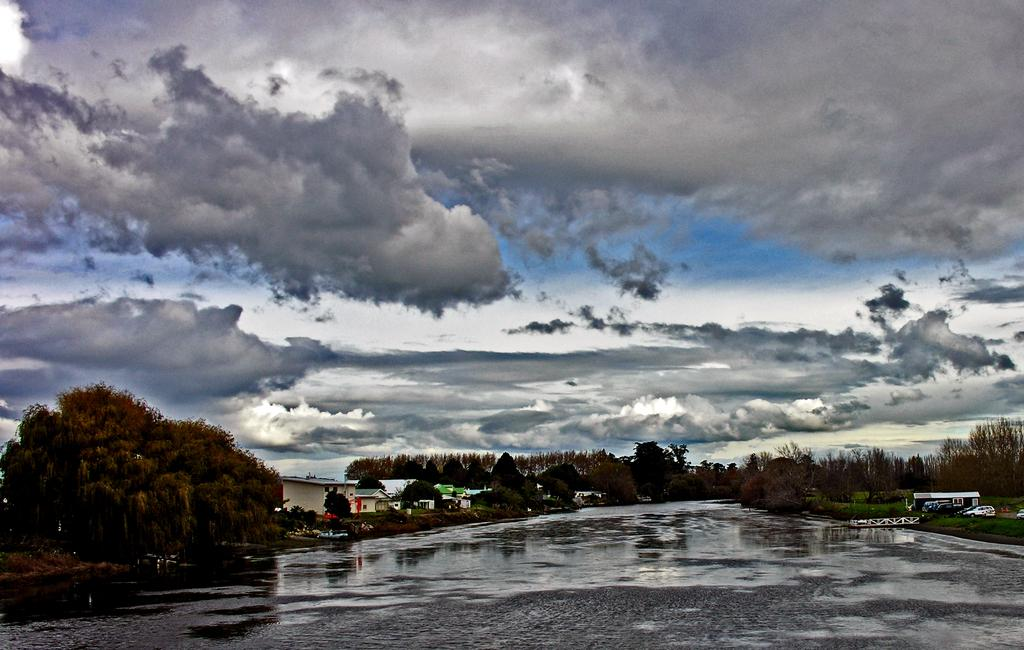What is located in the foreground of the picture? There is a water body in the foreground of the picture. What can be seen in the center of the picture? There are trees, plants, and buildings in the center of the picture. What is the condition of the sky in the picture? The sky is cloudy in the picture. What type of blade can be seen cutting through the glass in the image? There is no blade or glass present in the image. What kind of pest is visible in the image? There are no pests visible in the image. 